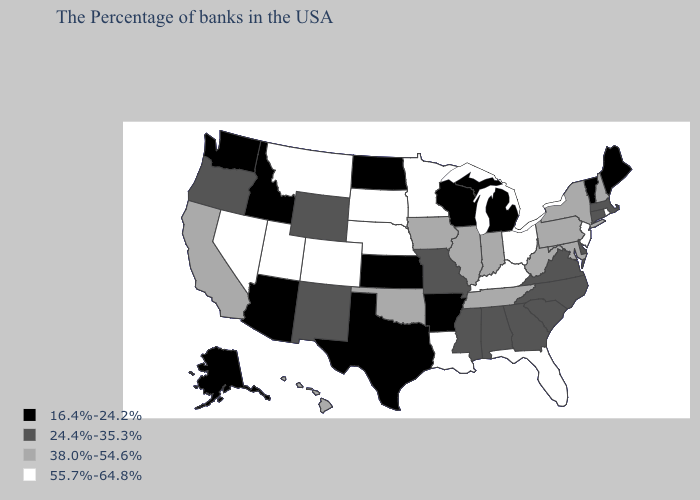Which states hav the highest value in the MidWest?
Answer briefly. Ohio, Minnesota, Nebraska, South Dakota. Does Michigan have the highest value in the MidWest?
Quick response, please. No. Name the states that have a value in the range 38.0%-54.6%?
Short answer required. New Hampshire, New York, Maryland, Pennsylvania, West Virginia, Indiana, Tennessee, Illinois, Iowa, Oklahoma, California, Hawaii. Does Kentucky have the same value as Louisiana?
Be succinct. Yes. What is the value of Montana?
Answer briefly. 55.7%-64.8%. What is the lowest value in the Northeast?
Answer briefly. 16.4%-24.2%. What is the lowest value in states that border California?
Give a very brief answer. 16.4%-24.2%. Name the states that have a value in the range 55.7%-64.8%?
Answer briefly. Rhode Island, New Jersey, Ohio, Florida, Kentucky, Louisiana, Minnesota, Nebraska, South Dakota, Colorado, Utah, Montana, Nevada. Among the states that border Nevada , which have the lowest value?
Keep it brief. Arizona, Idaho. What is the highest value in the USA?
Concise answer only. 55.7%-64.8%. What is the highest value in states that border Wyoming?
Be succinct. 55.7%-64.8%. Does Ohio have a higher value than Minnesota?
Short answer required. No. What is the value of Virginia?
Keep it brief. 24.4%-35.3%. Which states have the lowest value in the Northeast?
Be succinct. Maine, Vermont. 